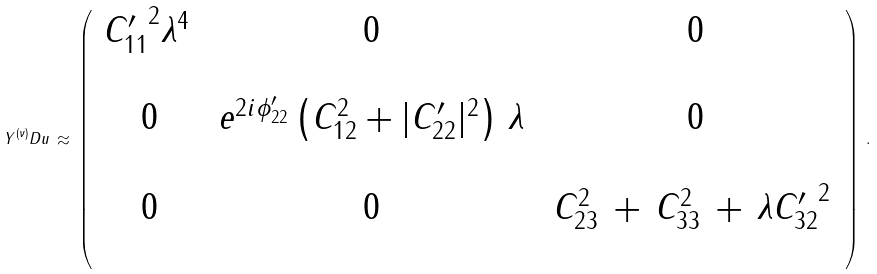Convert formula to latex. <formula><loc_0><loc_0><loc_500><loc_500>Y ^ { ( \nu ) } _ { \ } D u \, \approx \, \left ( \, \begin{array} { c c c } { C _ { 1 1 } ^ { \prime } } ^ { 2 } \lambda ^ { 4 } \, & \, 0 \, & \, 0 \\ \, & \, & \, \\ \, 0 \, & \, e ^ { 2 i \phi _ { 2 2 } ^ { \prime } } \left ( C _ { 1 2 } ^ { 2 } + | C _ { 2 2 } ^ { \prime } | ^ { 2 } \right ) \, \lambda \, & \, 0 \\ \, & \, & \, \\ \, 0 \, & \, 0 \, & \, C _ { 2 3 } ^ { 2 } \, + \, C _ { 3 3 } ^ { 2 } \, + \, \lambda { C _ { 3 2 } ^ { \prime } } ^ { 2 } \, \\ \, & \, & \, \end{array} \right ) \, .</formula> 